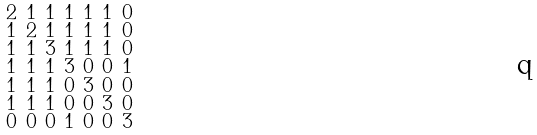<formula> <loc_0><loc_0><loc_500><loc_500>\begin{smallmatrix} 2 & 1 & 1 & 1 & 1 & 1 & 0 \\ 1 & 2 & 1 & 1 & 1 & 1 & 0 \\ 1 & 1 & 3 & 1 & 1 & 1 & 0 \\ 1 & 1 & 1 & 3 & 0 & 0 & 1 \\ 1 & 1 & 1 & 0 & 3 & 0 & 0 \\ 1 & 1 & 1 & 0 & 0 & 3 & 0 \\ 0 & 0 & 0 & 1 & 0 & 0 & 3 \end{smallmatrix}</formula> 